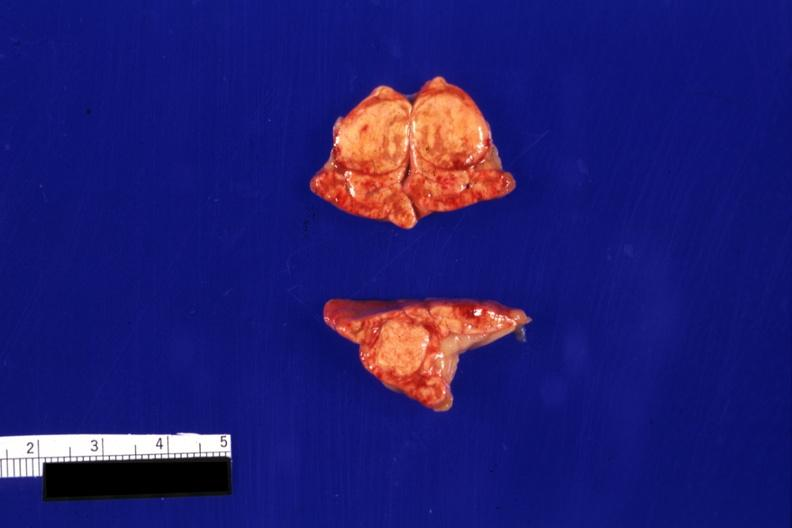where does this belong to?
Answer the question using a single word or phrase. Endocrine system 